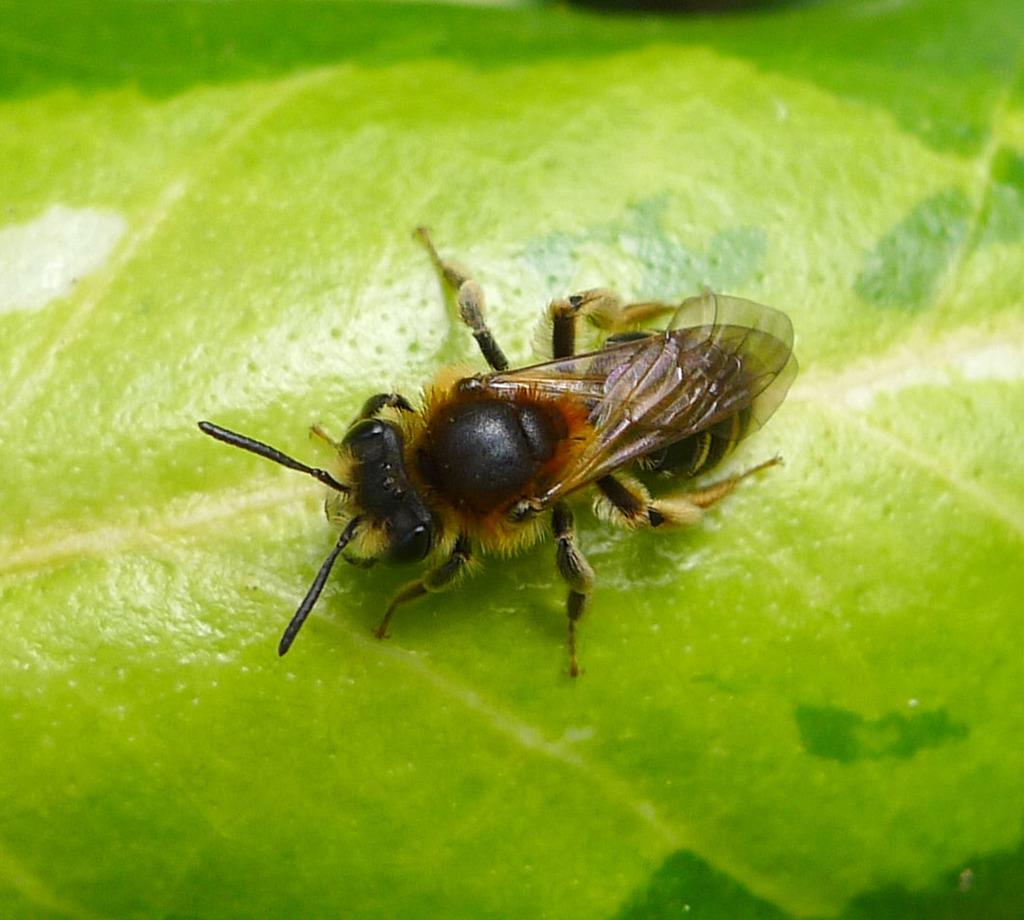What is present on the green leaf in the image? There is an insect on the green leaf in the image. Can you describe the insect's appearance? The insect might be a honey bee. What is the insect's location in relation to the green leaf? The insect is on the green leaf. Can you tell me how the insect folds the wood in the image? There is no wood present in the image, and the insect is not folding anything. 